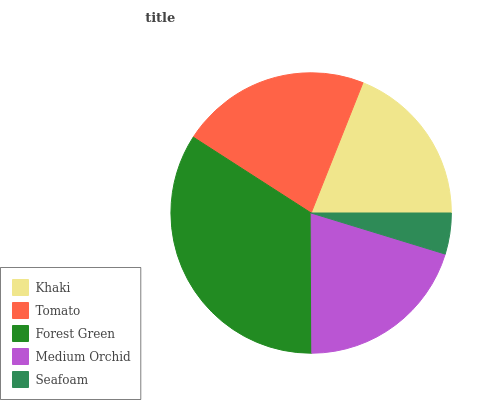Is Seafoam the minimum?
Answer yes or no. Yes. Is Forest Green the maximum?
Answer yes or no. Yes. Is Tomato the minimum?
Answer yes or no. No. Is Tomato the maximum?
Answer yes or no. No. Is Tomato greater than Khaki?
Answer yes or no. Yes. Is Khaki less than Tomato?
Answer yes or no. Yes. Is Khaki greater than Tomato?
Answer yes or no. No. Is Tomato less than Khaki?
Answer yes or no. No. Is Medium Orchid the high median?
Answer yes or no. Yes. Is Medium Orchid the low median?
Answer yes or no. Yes. Is Khaki the high median?
Answer yes or no. No. Is Seafoam the low median?
Answer yes or no. No. 